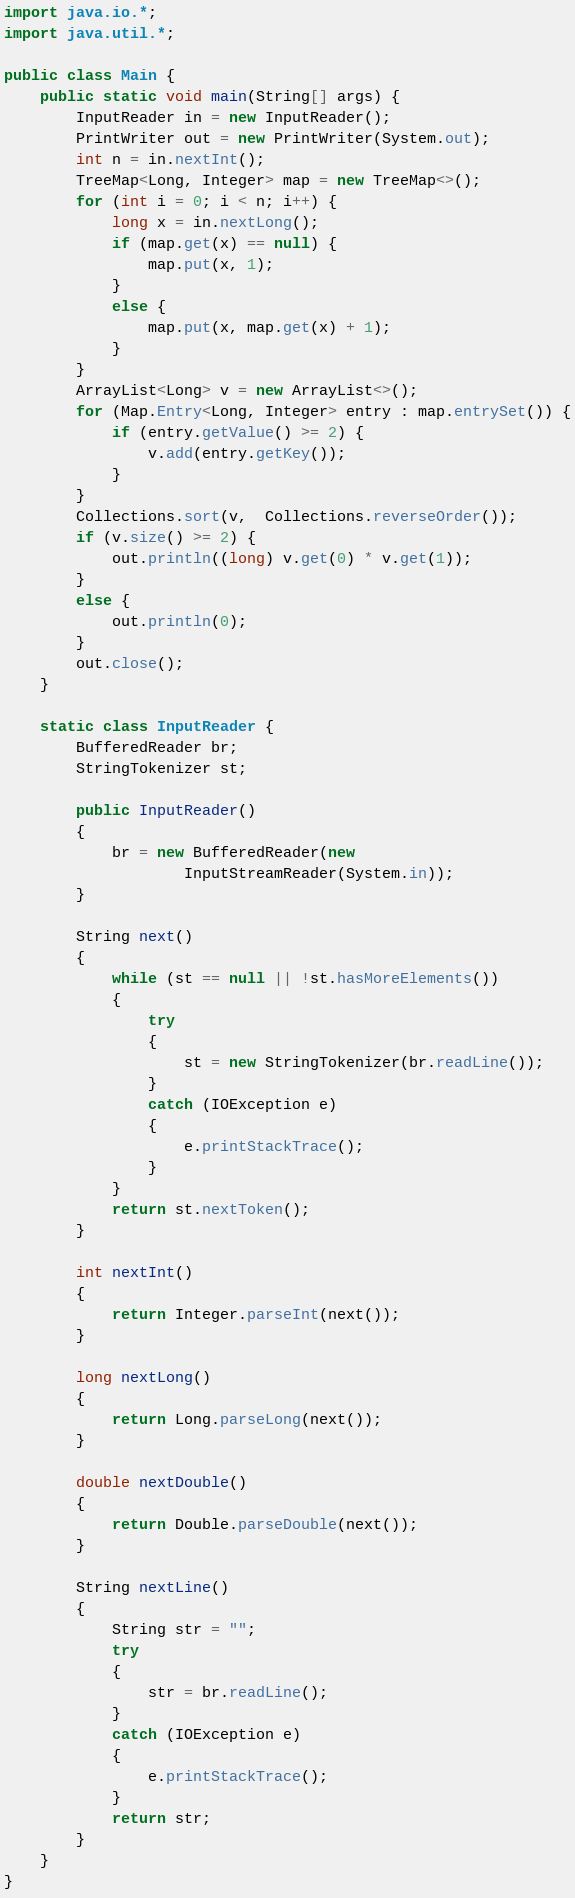Convert code to text. <code><loc_0><loc_0><loc_500><loc_500><_Java_>import java.io.*;
import java.util.*;

public class Main {
    public static void main(String[] args) {
        InputReader in = new InputReader();
        PrintWriter out = new PrintWriter(System.out);
        int n = in.nextInt();
        TreeMap<Long, Integer> map = new TreeMap<>();
        for (int i = 0; i < n; i++) {
            long x = in.nextLong();
            if (map.get(x) == null) {
                map.put(x, 1);
            }
            else {
                map.put(x, map.get(x) + 1);
            }
        }
        ArrayList<Long> v = new ArrayList<>();
        for (Map.Entry<Long, Integer> entry : map.entrySet()) {
            if (entry.getValue() >= 2) {
                v.add(entry.getKey());
            }
        }
        Collections.sort(v,  Collections.reverseOrder());
        if (v.size() >= 2) {
            out.println((long) v.get(0) * v.get(1));
        }
        else {
            out.println(0);
        }
        out.close();
    }

    static class InputReader {
        BufferedReader br;
        StringTokenizer st;

        public InputReader()
        {
            br = new BufferedReader(new
                    InputStreamReader(System.in));
        }

        String next()
        {
            while (st == null || !st.hasMoreElements())
            {
                try
                {
                    st = new StringTokenizer(br.readLine());
                }
                catch (IOException e)
                {
                    e.printStackTrace();
                }
            }
            return st.nextToken();
        }

        int nextInt()
        {
            return Integer.parseInt(next());
        }

        long nextLong()
        {
            return Long.parseLong(next());
        }

        double nextDouble()
        {
            return Double.parseDouble(next());
        }

        String nextLine()
        {
            String str = "";
            try
            {
                str = br.readLine();
            }
            catch (IOException e)
            {
                e.printStackTrace();
            }
            return str;
        }
    }
}

</code> 